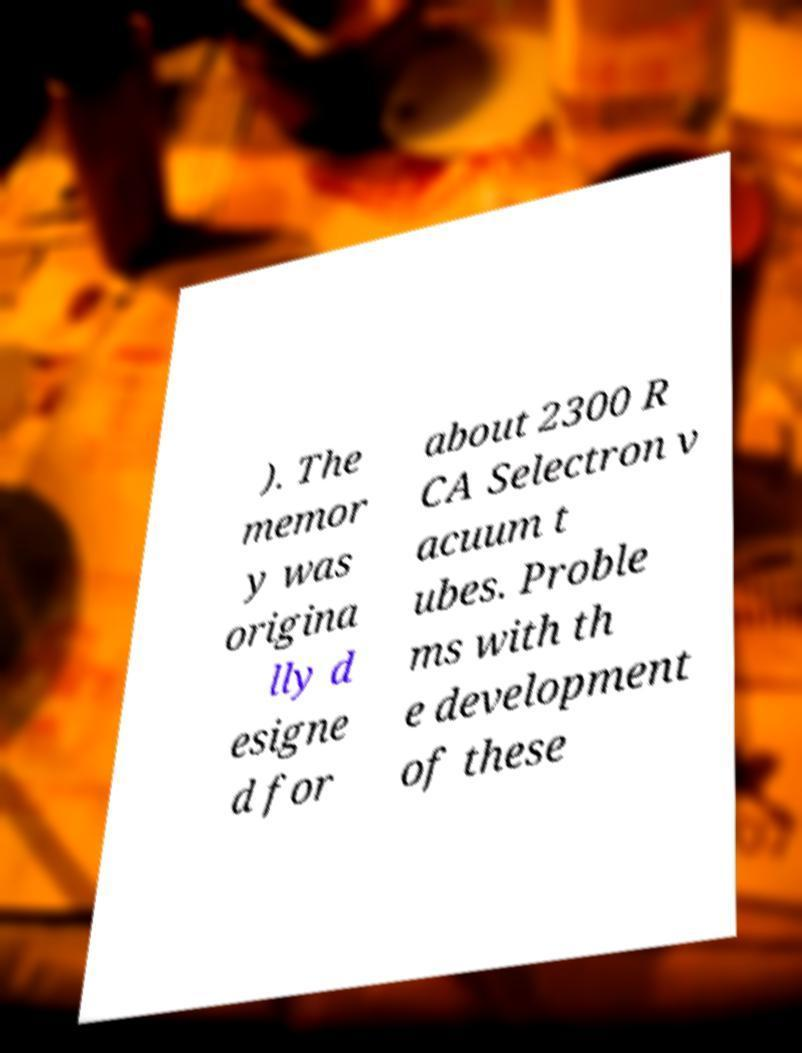Can you accurately transcribe the text from the provided image for me? ). The memor y was origina lly d esigne d for about 2300 R CA Selectron v acuum t ubes. Proble ms with th e development of these 